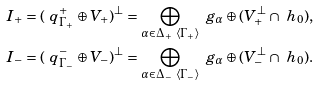<formula> <loc_0><loc_0><loc_500><loc_500>I _ { + } & = ( \ q _ { \Gamma _ { + } } ^ { + } \oplus V _ { + } ) ^ { \perp } = \bigoplus _ { \alpha \in \Delta _ { + } \ \left < \Gamma _ { + } \right > } \ g _ { \alpha } \oplus ( V _ { + } ^ { \perp } \cap \ h _ { 0 } ) , \\ I _ { - } & = ( \ q _ { \Gamma _ { - } } ^ { - } \oplus V _ { - } ) ^ { \perp } = \bigoplus _ { \alpha \in \Delta _ { - } \ \left < \Gamma _ { - } \right > } \ g _ { \alpha } \oplus ( V _ { - } ^ { \perp } \cap \ h _ { 0 } ) .</formula> 